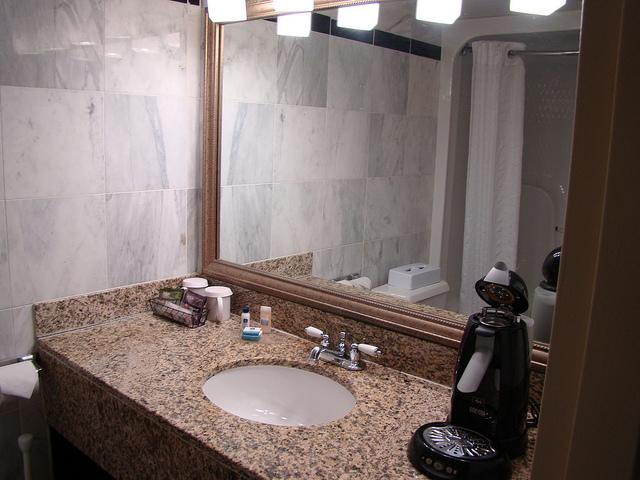Who folded the toilet paper roll into a point to the left of the sink?

Choices:
A) nanny
B) clerk
C) cleaning staff
D) butler cleaning staff 